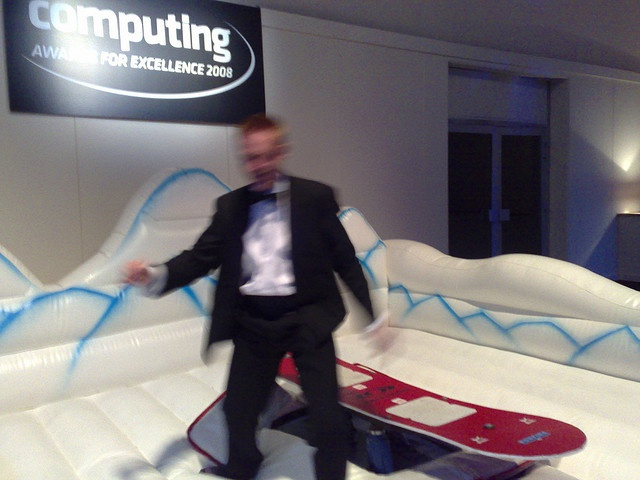Describe the objects in this image and their specific colors. I can see people in gray, black, darkgray, and lavender tones, snowboard in gray, brown, tan, and darkgray tones, and tie in black, navy, purple, and gray tones in this image. 